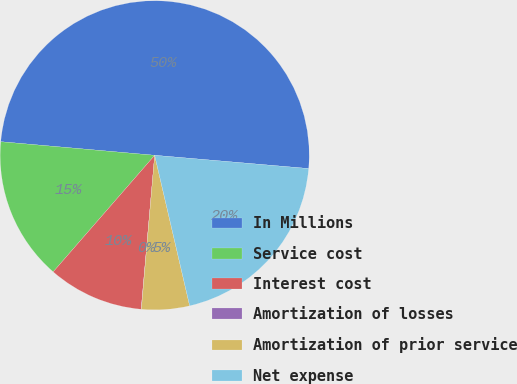Convert chart to OTSL. <chart><loc_0><loc_0><loc_500><loc_500><pie_chart><fcel>In Millions<fcel>Service cost<fcel>Interest cost<fcel>Amortization of losses<fcel>Amortization of prior service<fcel>Net expense<nl><fcel>49.97%<fcel>15.0%<fcel>10.01%<fcel>0.02%<fcel>5.01%<fcel>20.0%<nl></chart> 